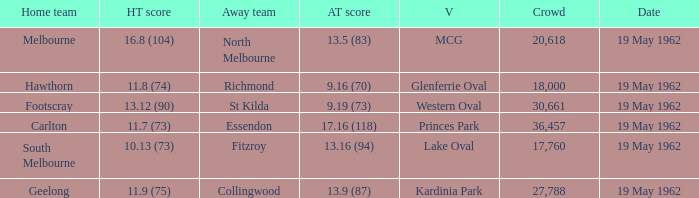What is the score for the home team at mcg? 16.8 (104). 